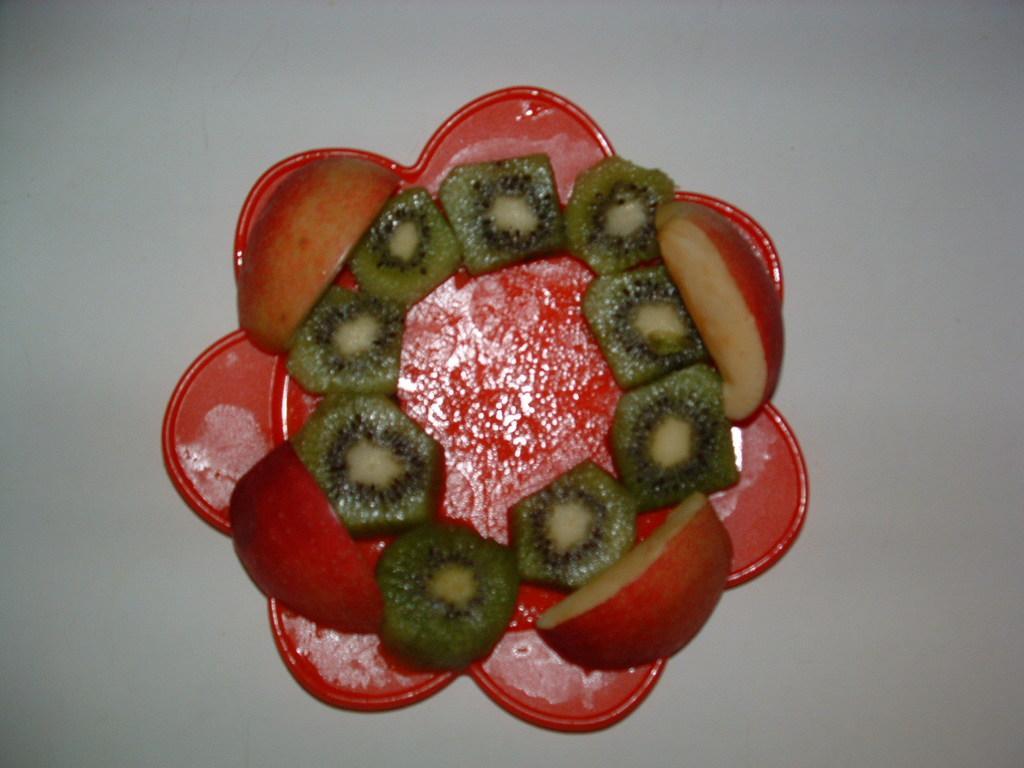In one or two sentences, can you explain what this image depicts? In this picture I can see apple and kiwi fruit slices on the plate, on an object. 